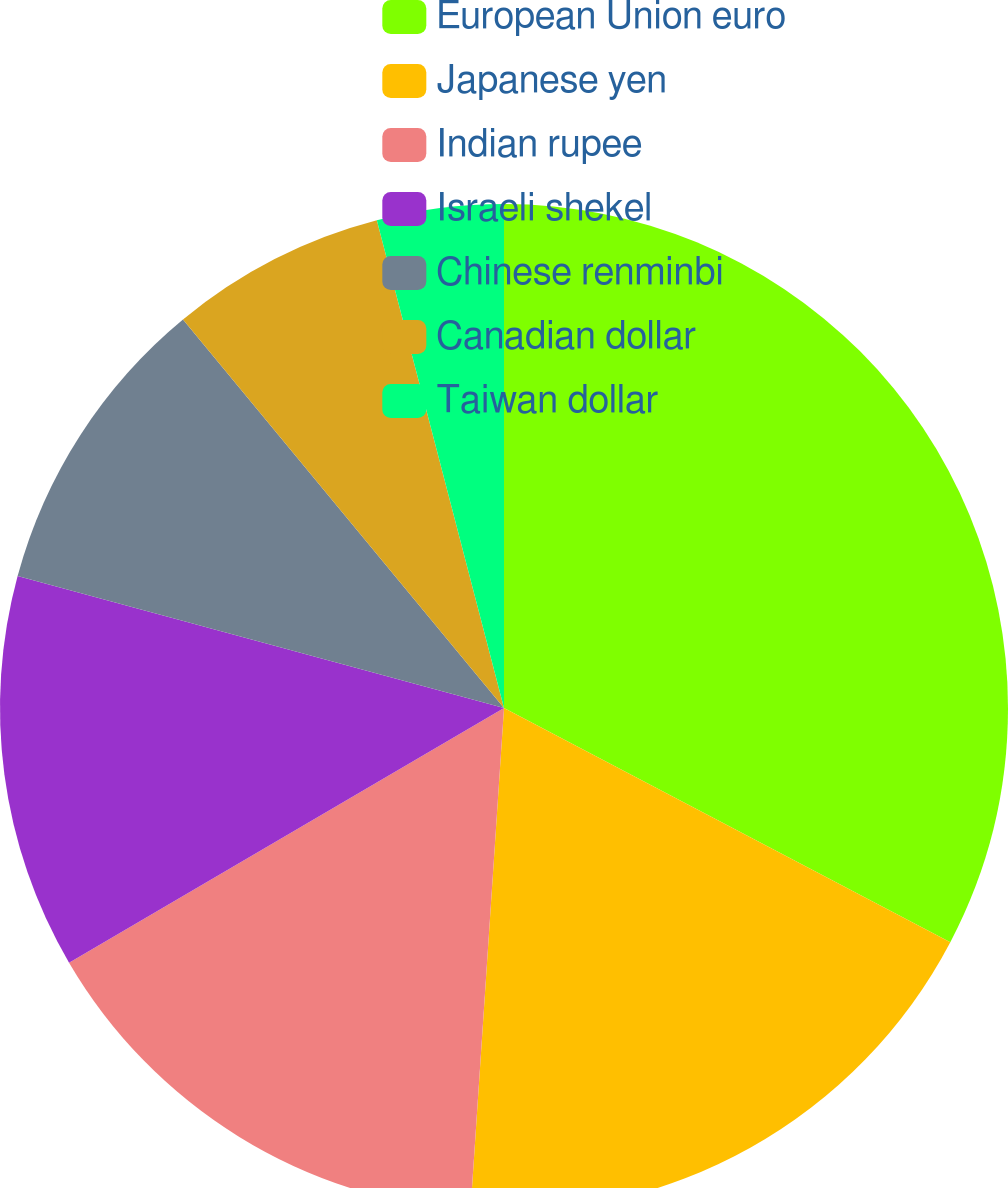<chart> <loc_0><loc_0><loc_500><loc_500><pie_chart><fcel>European Union euro<fcel>Japanese yen<fcel>Indian rupee<fcel>Israeli shekel<fcel>Chinese renminbi<fcel>Canadian dollar<fcel>Taiwan dollar<nl><fcel>32.69%<fcel>18.37%<fcel>15.51%<fcel>12.65%<fcel>9.79%<fcel>6.93%<fcel>4.06%<nl></chart> 